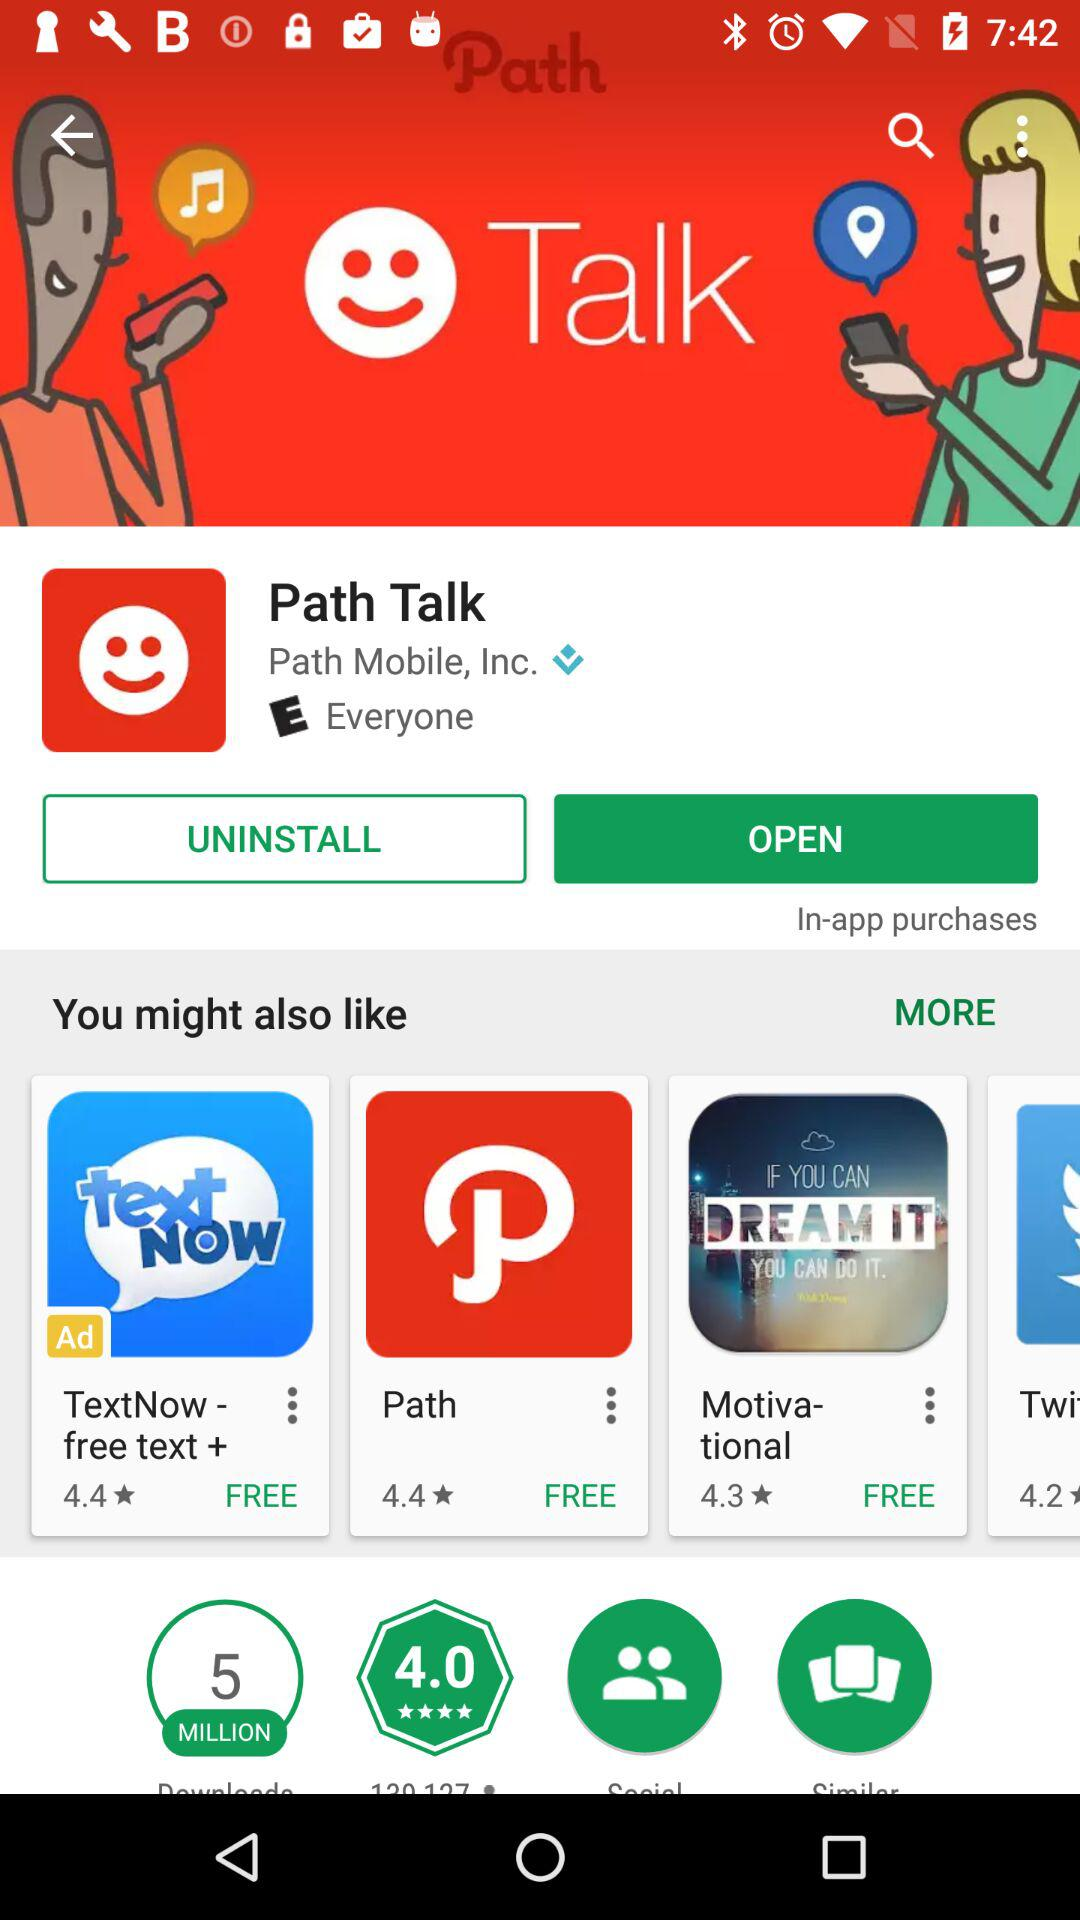How many people downloaded the application? The application was downloaded by 5 million people. 